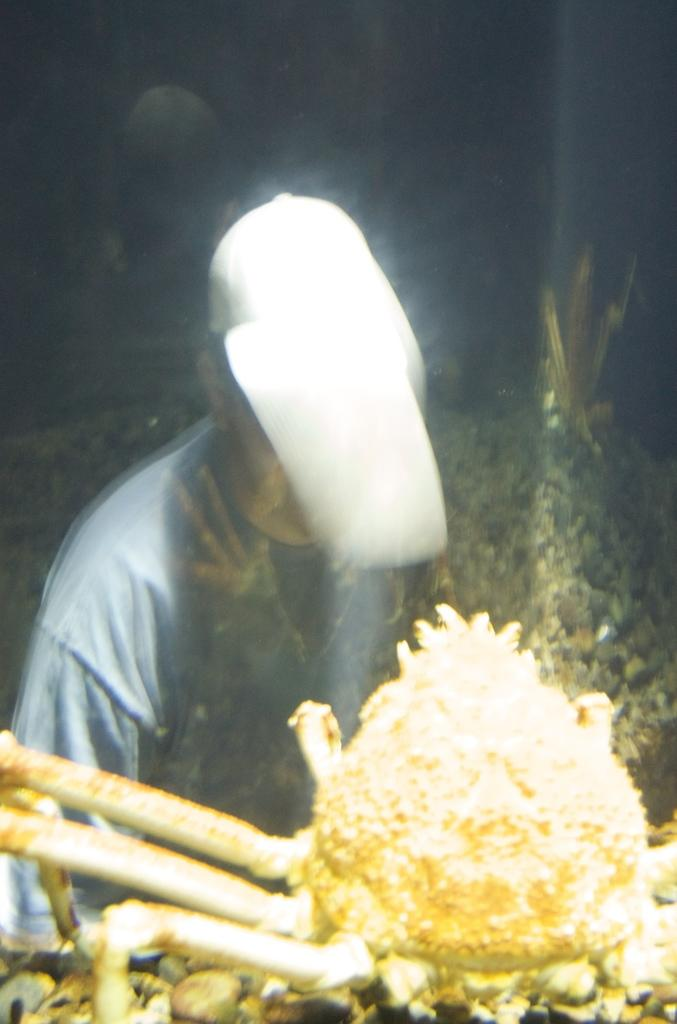What is the person in the image doing? The person is playing a guitar. What can be seen in the background of the image? There is a wall and a window in the background of the image. What type of flowers can be seen growing on the wall in the image? There are no flowers visible on the wall in the image; it only shows a person playing a guitar and a wall with a window in the background. 